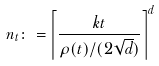<formula> <loc_0><loc_0><loc_500><loc_500>n _ { t } \colon = \left \lceil \frac { k t } { \rho ( t ) / ( 2 \sqrt { d } ) } \right \rceil ^ { d }</formula> 